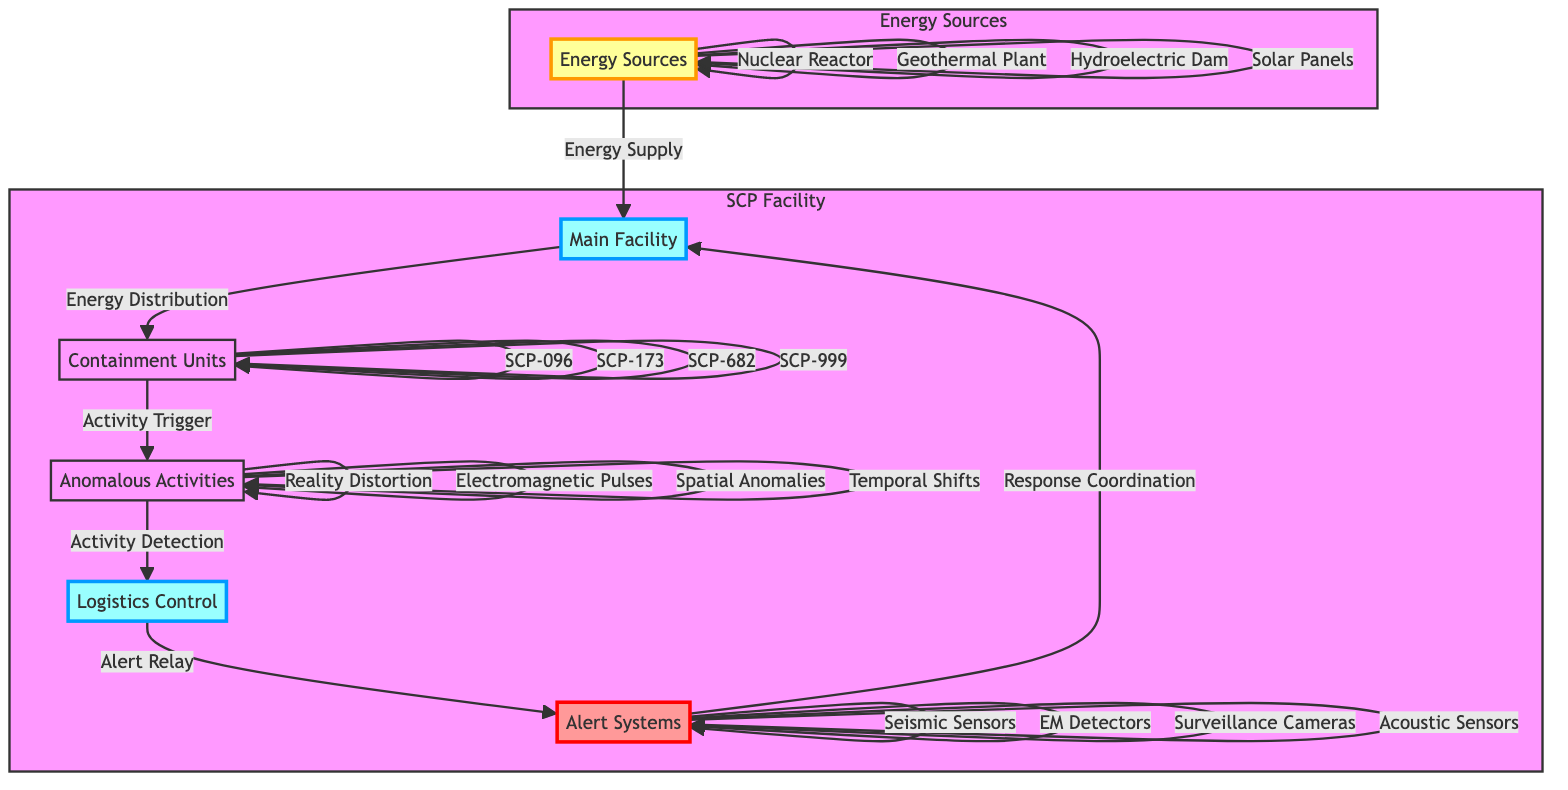What are the energy sources listed in the diagram? The diagram specifies four energy sources: Nuclear Reactor, Geothermal Plant, Hydroelectric Dam, and Solar Panels. These are connected to the Energy Sources node.
Answer: Nuclear Reactor, Geothermal Plant, Hydroelectric Dam, Solar Panels How many containment units are shown in the diagram? The diagram displays four containment units: SCP-096, SCP-173, SCP-682, and SCP-999. They are all linked to the Containment Units node.
Answer: 4 What is the primary function of the Logistics Control node? The Logistics Control node receives input from Anomalous Activities and forwards alert information to Alert Systems, acting as a coordination node in response to detected anomalous activities.
Answer: Alert Relay What activities are classified as anomalous according to the diagram? The diagram identifies four types of anomalous activities: Reality Distortion, Electromagnetic Pulses, Spatial Anomalies, and Temporal Shifts, connected to the Anomalous Activities node.
Answer: Reality Distortion, Electromagnetic Pulses, Spatial Anomalies, Temporal Shifts How does energy flow from the Energy Sources to the Alert Systems? Energy initially flows from Energy Sources to the Main Facility, which then distributes energy to Containment Units. Anomalous Activities in containment trigger alerts that are relayed through Logistics Control to Alert Systems.
Answer: Energy Supply, Energy Distribution, Activity Trigger, Activity Detection, Alert Relay, Response Coordination What types of sensors are included in the Alert Systems? The Alert Systems comprise Seismic Sensors, EM Detectors, Surveillance Cameras, and Acoustic Sensors as listed in the diagram, which are linked to the Alert Systems node.
Answer: Seismic Sensors, EM Detectors, Surveillance Cameras, Acoustic Sensors Which containment unit has the potential to generate Reality Distortion? The diagram does not specify which containment unit generates Reality Distortion directly; however, it suggests that the activities connected to containment units can lead to anomalous activities. Thus, multiple possibilities are present without direct designation.
Answer: Not specified What is the relationship between Main Facility and Anomalous Activities? The Main Facility distributes energy to the Containment Units, which are responsible for triggering Anomalous Activities; this indicates a direct functional relationship where the facility supports containment measures that can result in such anomalies.
Answer: Activity Trigger 